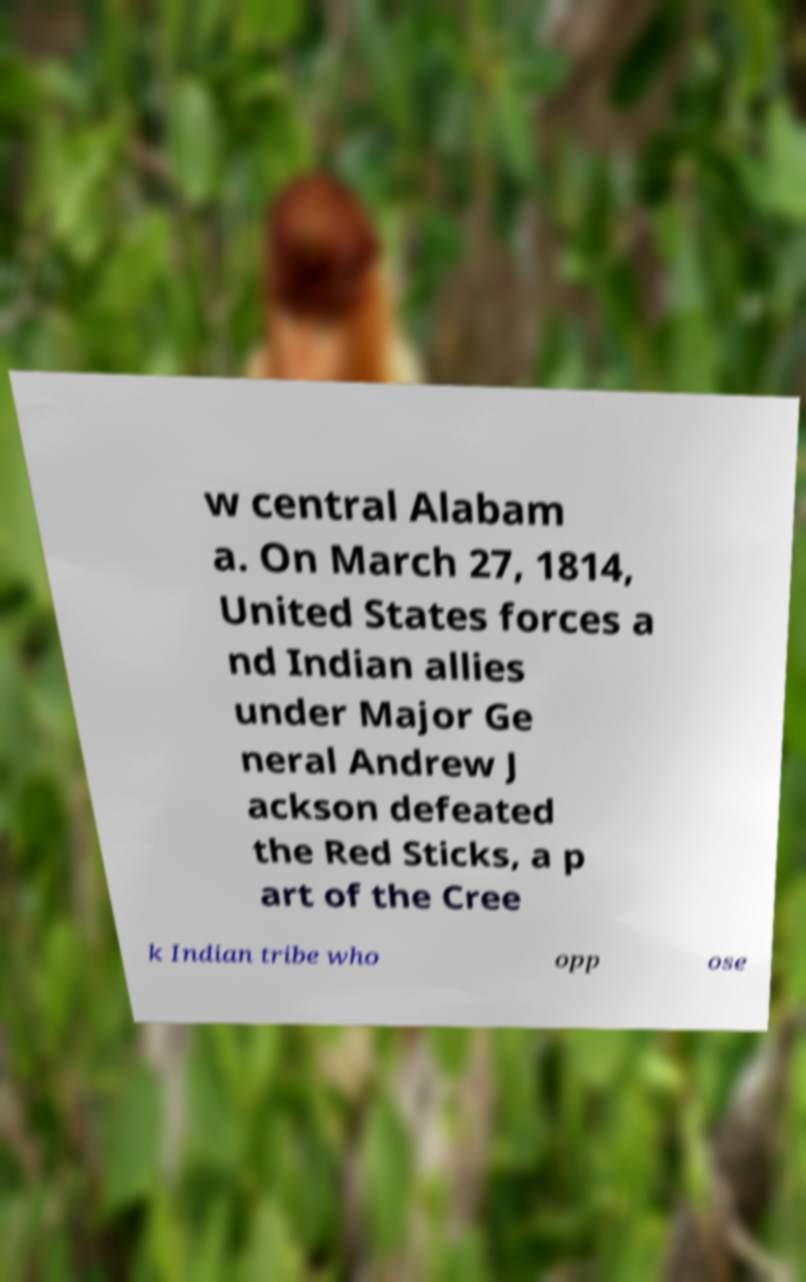There's text embedded in this image that I need extracted. Can you transcribe it verbatim? w central Alabam a. On March 27, 1814, United States forces a nd Indian allies under Major Ge neral Andrew J ackson defeated the Red Sticks, a p art of the Cree k Indian tribe who opp ose 